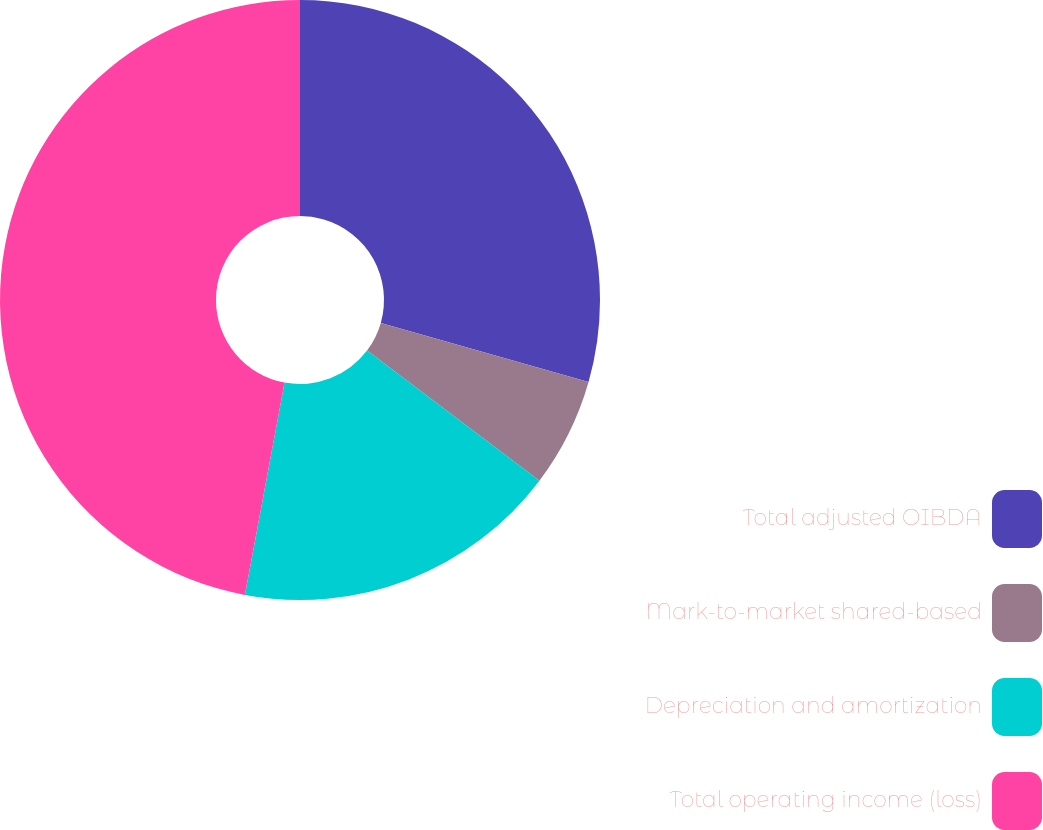Convert chart. <chart><loc_0><loc_0><loc_500><loc_500><pie_chart><fcel>Total adjusted OIBDA<fcel>Mark-to-market shared-based<fcel>Depreciation and amortization<fcel>Total operating income (loss)<nl><fcel>29.41%<fcel>5.88%<fcel>17.65%<fcel>47.06%<nl></chart> 